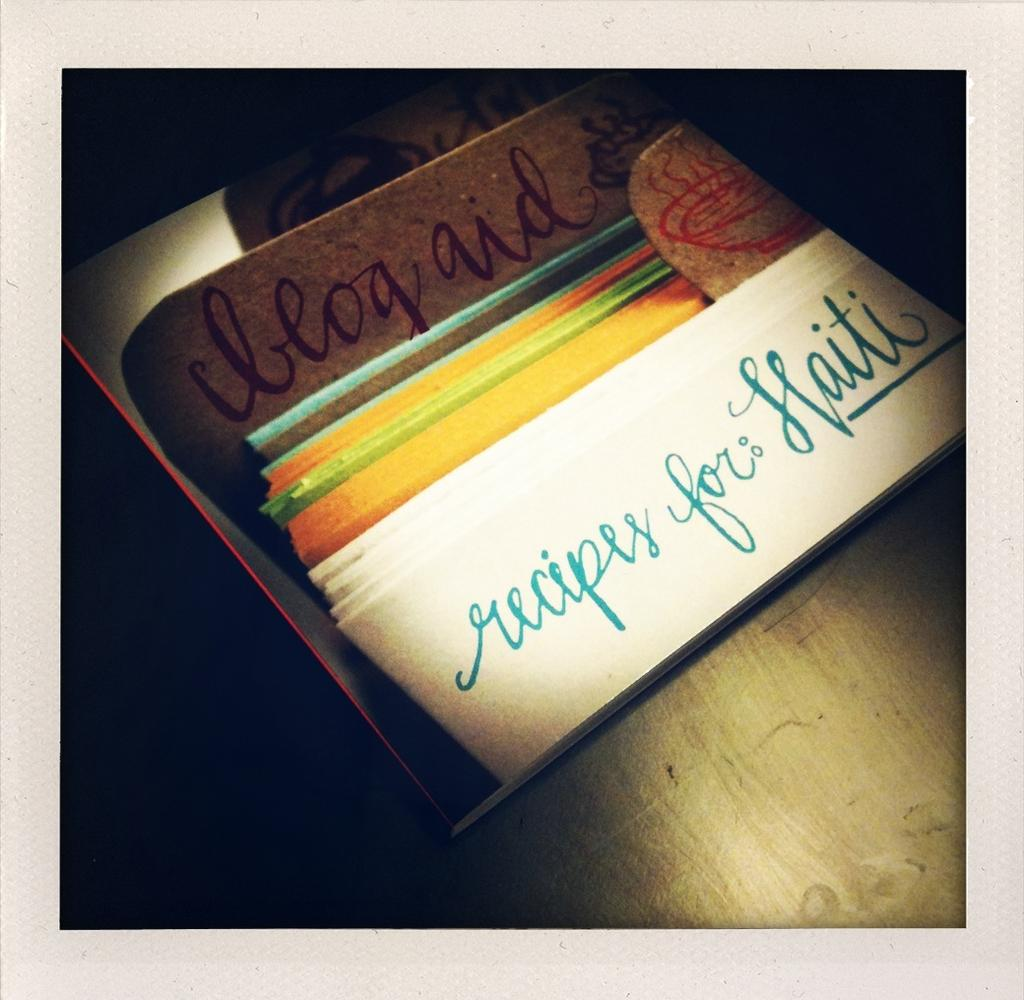<image>
Share a concise interpretation of the image provided. A stack of recipe cards with a handwritten caligraphy sign "recipes for Haiti". 